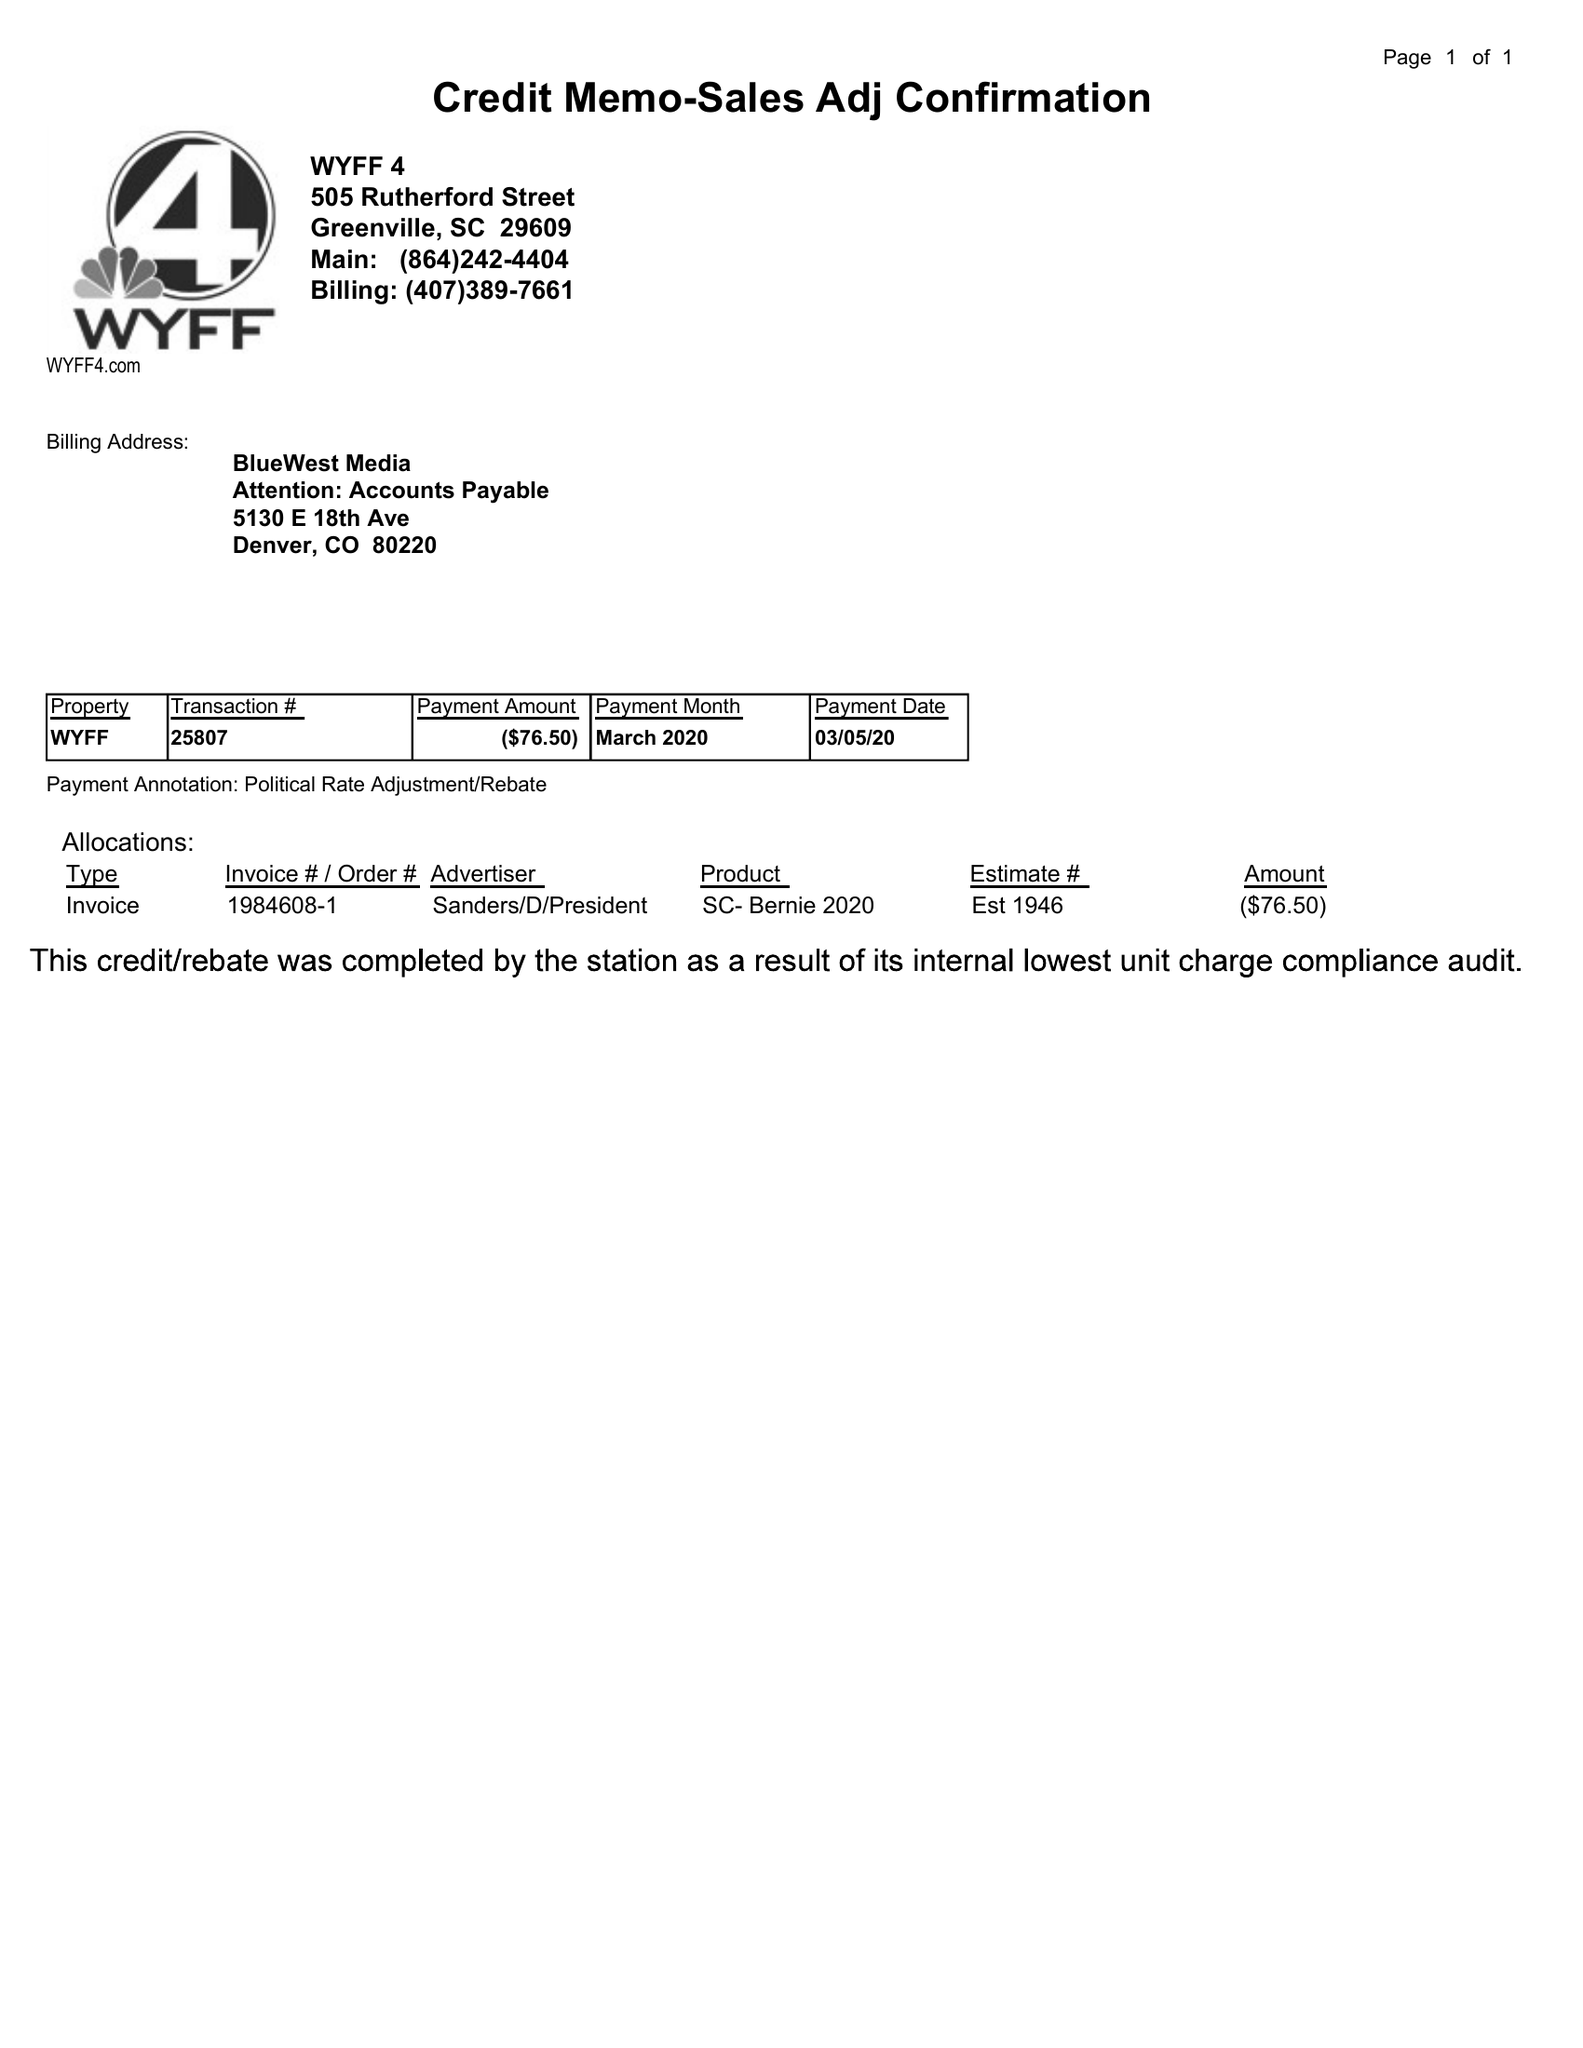What is the value for the flight_from?
Answer the question using a single word or phrase. None 